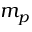<formula> <loc_0><loc_0><loc_500><loc_500>m _ { p }</formula> 